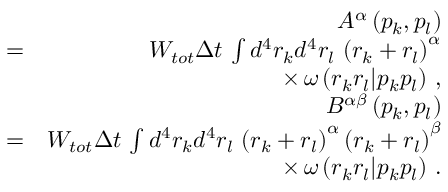<formula> <loc_0><loc_0><loc_500><loc_500>\begin{array} { r l r } & { A ^ { \alpha } \left ( p _ { k } , p _ { l } \right ) } \\ & { = } & { W _ { t o t } \Delta t \, \int d ^ { 4 } r _ { k } d ^ { 4 } r _ { l } \, \left ( r _ { k } + r _ { l } \right ) ^ { \alpha } } \\ & { \times \, \omega \left ( r _ { k } r _ { l } | p _ { k } p _ { l } \right ) \, , } \\ & { B ^ { \alpha \beta } \left ( p _ { k } , p _ { l } \right ) } \\ & { = } & { W _ { t o t } \Delta t \, \int d ^ { 4 } r _ { k } d ^ { 4 } r _ { l } \, \left ( r _ { k } + r _ { l } \right ) ^ { \alpha } \left ( r _ { k } + r _ { l } \right ) ^ { \beta } } \\ & { \times \, \omega \left ( r _ { k } r _ { l } | p _ { k } p _ { l } \right ) \, . } \end{array}</formula> 